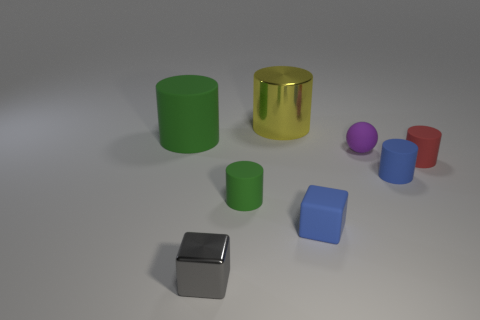Subtract 3 cylinders. How many cylinders are left? 2 Subtract all blue cylinders. How many cylinders are left? 4 Subtract all tiny blue cylinders. How many cylinders are left? 4 Subtract all purple cylinders. Subtract all purple cubes. How many cylinders are left? 5 Add 2 green cylinders. How many objects exist? 10 Subtract all cylinders. How many objects are left? 3 Add 2 blue things. How many blue things are left? 4 Add 4 small red rubber objects. How many small red rubber objects exist? 5 Subtract 0 red spheres. How many objects are left? 8 Subtract all small yellow matte things. Subtract all small red objects. How many objects are left? 7 